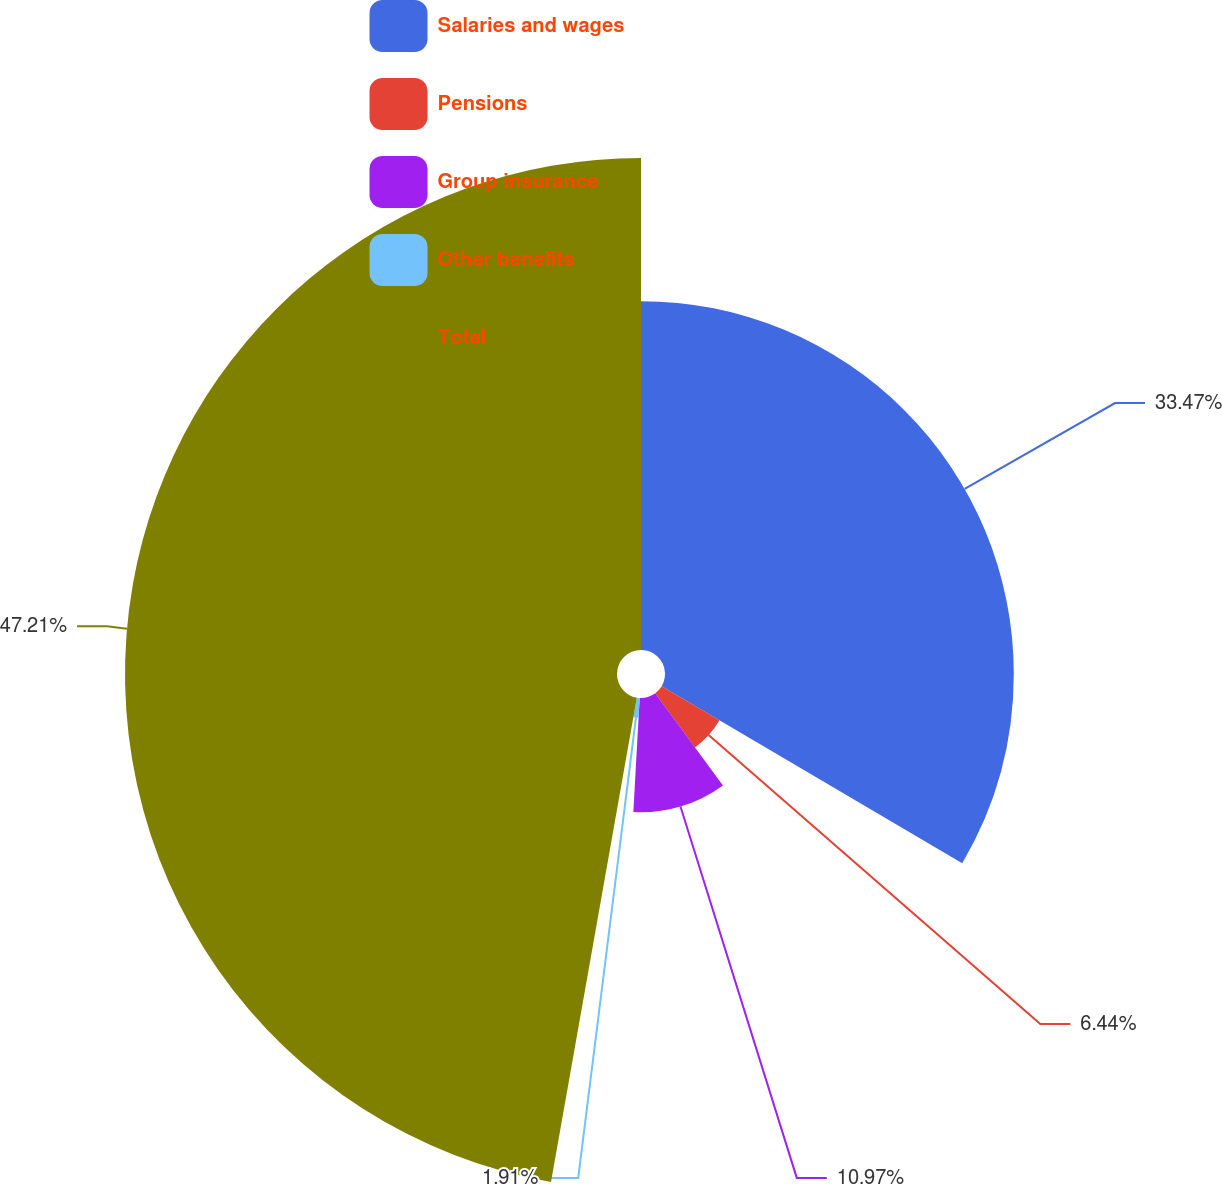Convert chart to OTSL. <chart><loc_0><loc_0><loc_500><loc_500><pie_chart><fcel>Salaries and wages<fcel>Pensions<fcel>Group insurance<fcel>Other benefits<fcel>Total<nl><fcel>33.47%<fcel>6.44%<fcel>10.97%<fcel>1.91%<fcel>47.21%<nl></chart> 